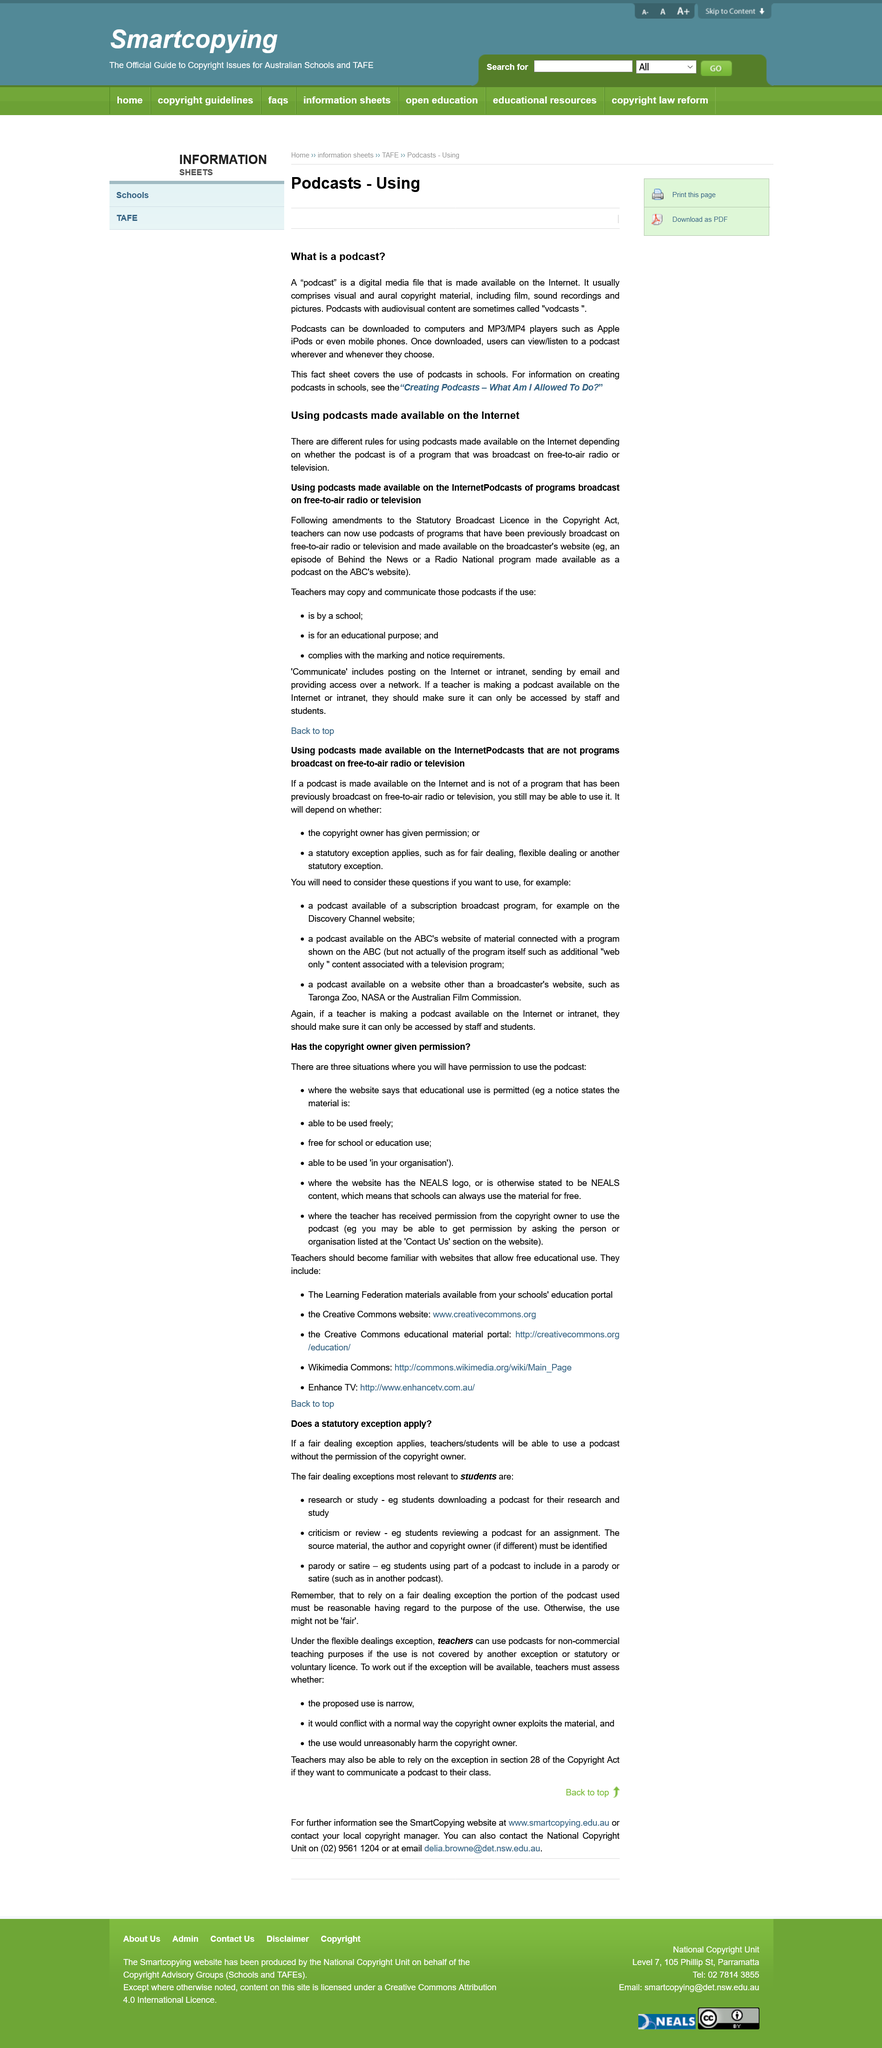Identify some key points in this picture. The Discovery Channel website, which is accessible only through subscription, is an example of a subscription broadcast program. Teachers can copy and communicate podcasts if they use them for an educational purpose and comply with the marking and notice requirements, as long as the use is by a school. Teachers should ensure that their podcast is only accessible to staff and students by making it available on the internet or intranet in a secure manner. Parody or satire is a fair dealing exception. The person or organization is listed in the 'Contact Us' section of the website in order to obtain permission. 